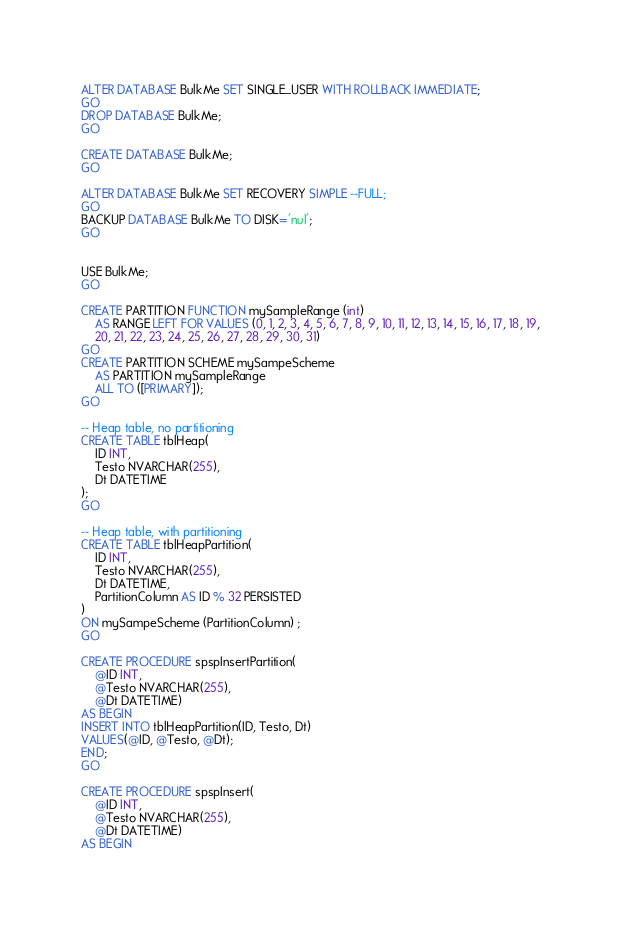<code> <loc_0><loc_0><loc_500><loc_500><_SQL_>ALTER DATABASE BulkMe SET SINGLE_USER WITH ROLLBACK IMMEDIATE;
GO
DROP DATABASE BulkMe;
GO

CREATE DATABASE BulkMe;
GO

ALTER DATABASE BulkMe SET RECOVERY SIMPLE --FULL;
GO
BACKUP DATABASE BulkMe TO DISK='nul';
GO


USE BulkMe;
GO 

CREATE PARTITION FUNCTION mySampleRange (int)  
    AS RANGE LEFT FOR VALUES (0, 1, 2, 3, 4, 5, 6, 7, 8, 9, 10, 11, 12, 13, 14, 15, 16, 17, 18, 19,
	20, 21, 22, 23, 24, 25, 26, 27, 28, 29, 30, 31)
GO  
CREATE PARTITION SCHEME mySampeScheme  
    AS PARTITION mySampleRange  
    ALL TO ([PRIMARY]);
GO  

-- Heap table, no partitioning
CREATE TABLE tblHeap(
	ID INT,
	Testo NVARCHAR(255),
	Dt DATETIME
);
GO

-- Heap table, with partitioning
CREATE TABLE tblHeapPartition(
	ID INT,
	Testo NVARCHAR(255),
	Dt DATETIME,
	PartitionColumn AS ID % 32 PERSISTED
)
ON mySampeScheme (PartitionColumn) ;  
GO

CREATE PROCEDURE spspInsertPartition(
	@ID INT,
	@Testo NVARCHAR(255),
	@Dt DATETIME)
AS BEGIN
INSERT INTO tblHeapPartition(ID, Testo, Dt)
VALUES(@ID, @Testo, @Dt);
END;
GO

CREATE PROCEDURE spspInsert(
	@ID INT,
	@Testo NVARCHAR(255),
	@Dt DATETIME)
AS BEGIN</code> 